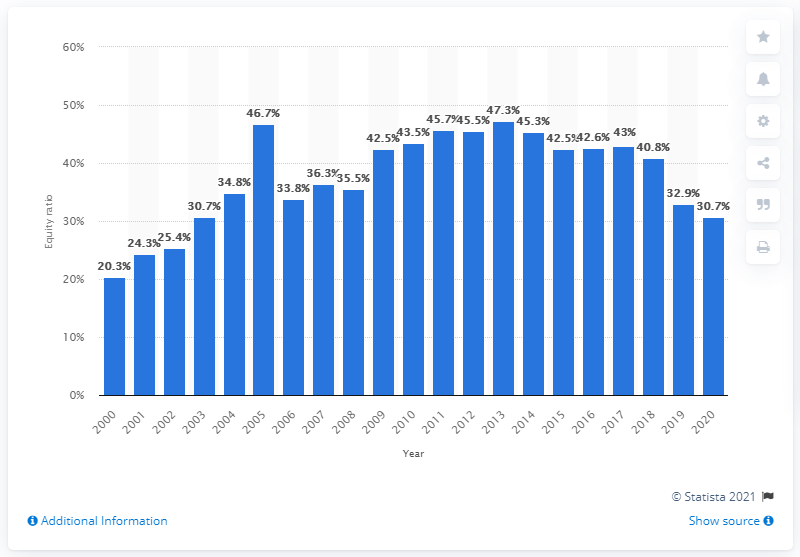Highlight a few significant elements in this photo. In the most recently reported period, adidas Group's equity ratio was 30.7%. In 2013, the adidas Group's equity ratio was 47.3%. 